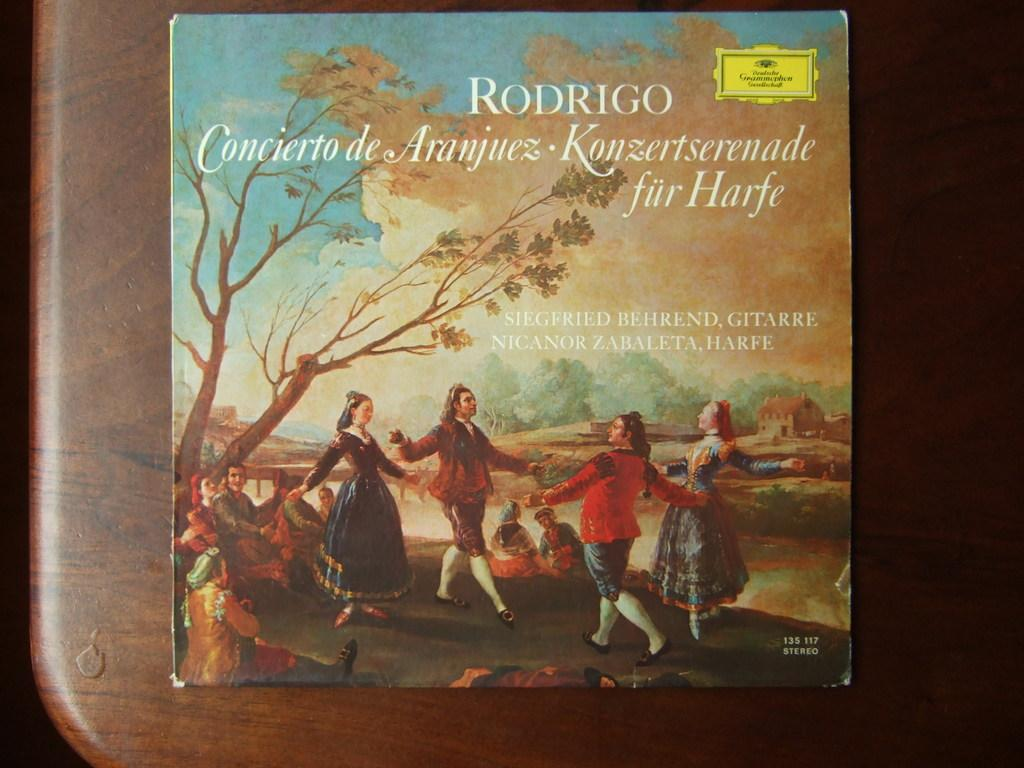<image>
Render a clear and concise summary of the photo. the cover of Rodrigo Concierto has renaissance people dancing on it 